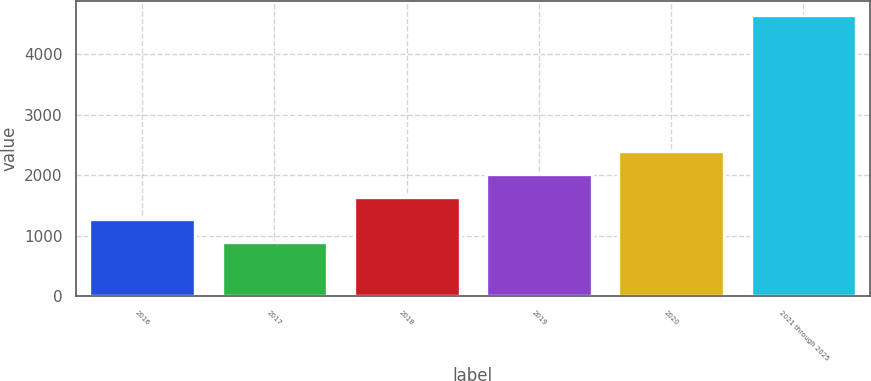Convert chart to OTSL. <chart><loc_0><loc_0><loc_500><loc_500><bar_chart><fcel>2016<fcel>2017<fcel>2018<fcel>2019<fcel>2020<fcel>2021 through 2025<nl><fcel>1275<fcel>900<fcel>1650<fcel>2025<fcel>2400<fcel>4650<nl></chart> 